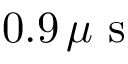<formula> <loc_0><loc_0><loc_500><loc_500>0 . 9 \, \mu s</formula> 